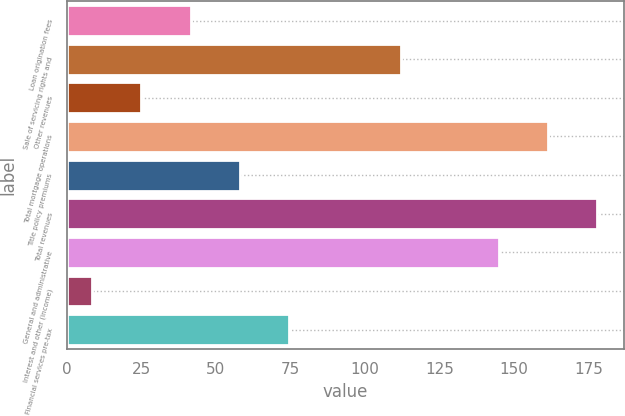Convert chart. <chart><loc_0><loc_0><loc_500><loc_500><bar_chart><fcel>Loan origination fees<fcel>Sale of servicing rights and<fcel>Other revenues<fcel>Total mortgage operations<fcel>Title policy premiums<fcel>Total revenues<fcel>General and administrative<fcel>Interest and other (income)<fcel>Financial services pre-tax<nl><fcel>41.48<fcel>112<fcel>24.99<fcel>161.47<fcel>57.97<fcel>177.96<fcel>144.98<fcel>8.5<fcel>74.46<nl></chart> 